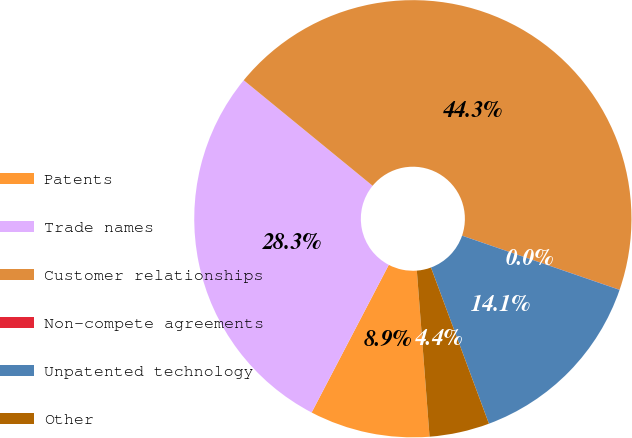Convert chart. <chart><loc_0><loc_0><loc_500><loc_500><pie_chart><fcel>Patents<fcel>Trade names<fcel>Customer relationships<fcel>Non-compete agreements<fcel>Unpatented technology<fcel>Other<nl><fcel>8.88%<fcel>28.26%<fcel>44.35%<fcel>0.01%<fcel>14.07%<fcel>4.44%<nl></chart> 